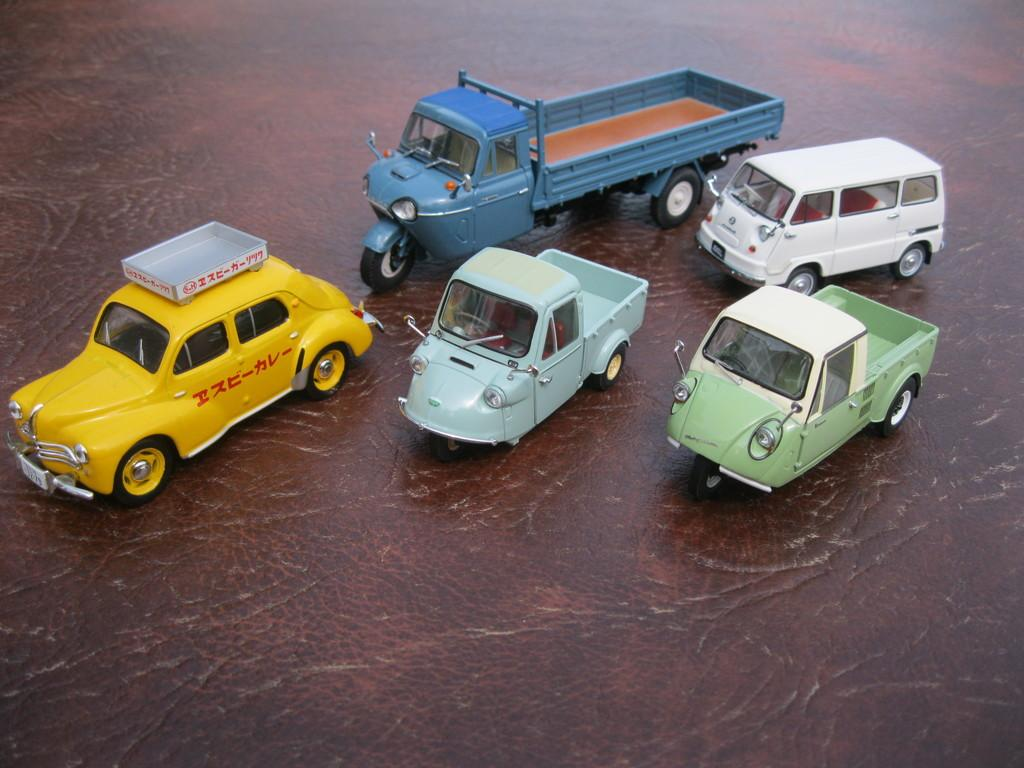<image>
Relay a brief, clear account of the picture shown. Five trucks sitting on a table with a yellow truck that has foreign letters looking to be HNC on the side 